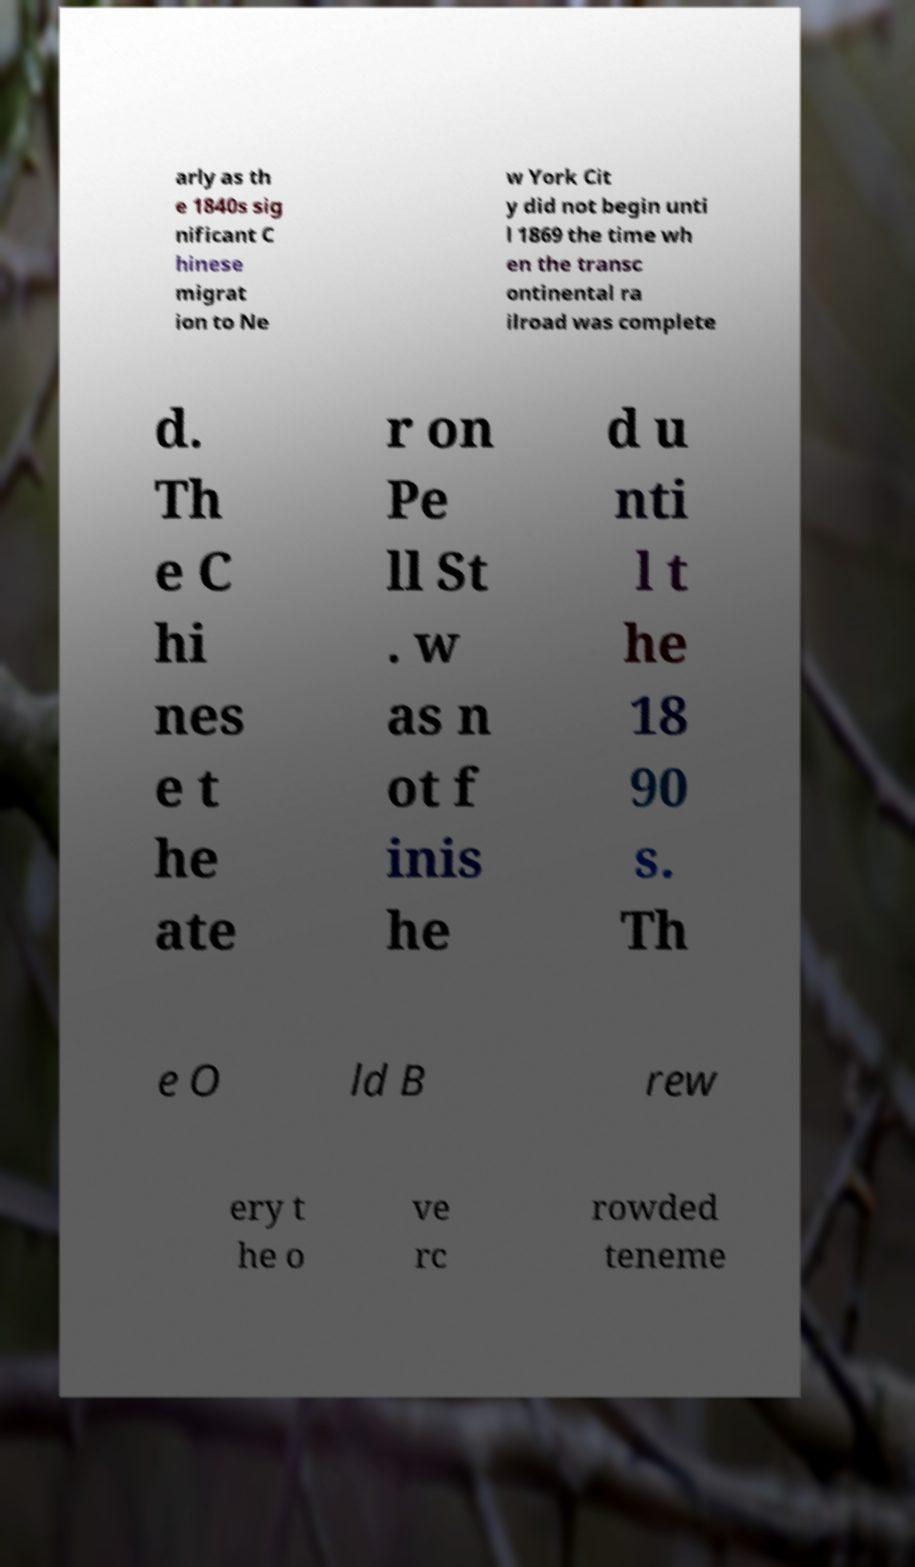Please read and relay the text visible in this image. What does it say? arly as th e 1840s sig nificant C hinese migrat ion to Ne w York Cit y did not begin unti l 1869 the time wh en the transc ontinental ra ilroad was complete d. Th e C hi nes e t he ate r on Pe ll St . w as n ot f inis he d u nti l t he 18 90 s. Th e O ld B rew ery t he o ve rc rowded teneme 